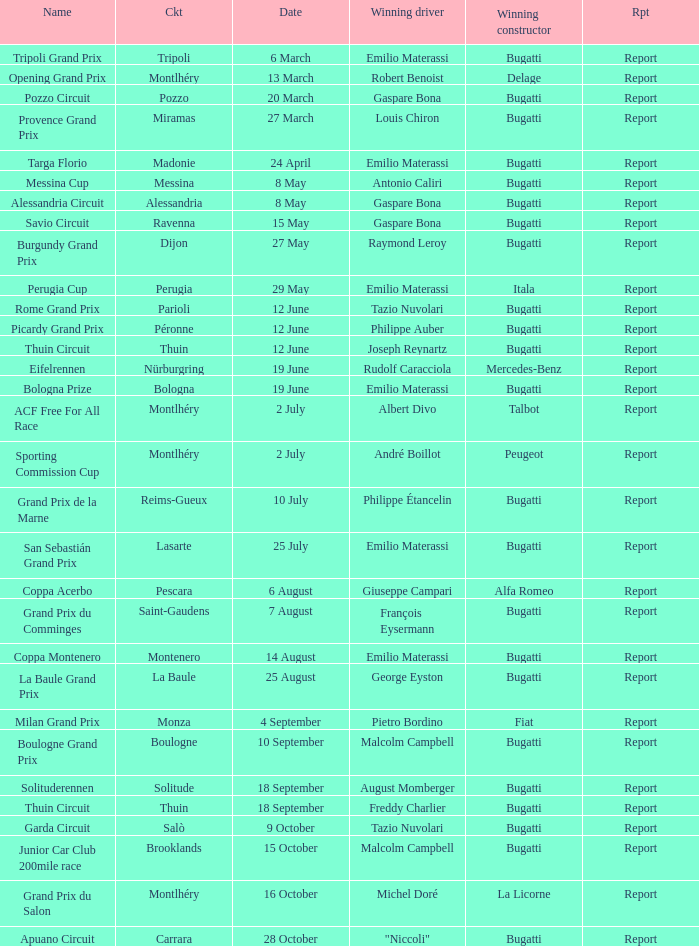Who was the winning constructor of the Grand Prix Du Salon ? La Licorne. 